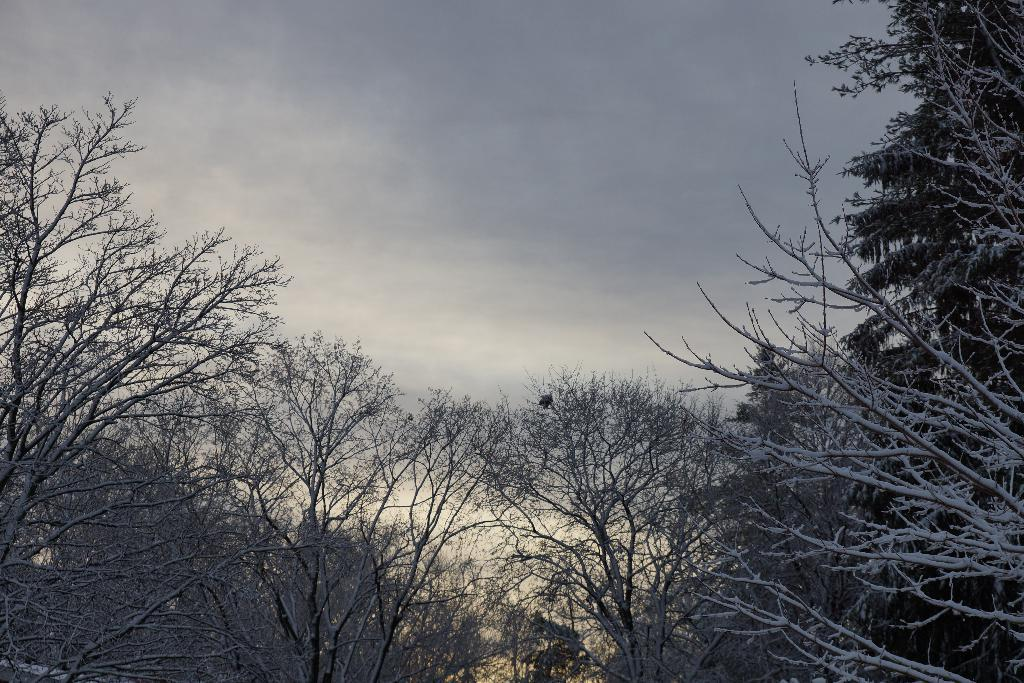What is located in the center of the image? There are trees in the center of the image. What can be seen in the background of the image? The sky is visible in the background of the image. What type of coach is leading the group of trees in the image? There is no coach or group of trees present in the image; it only features trees in the center and the sky in the background. 